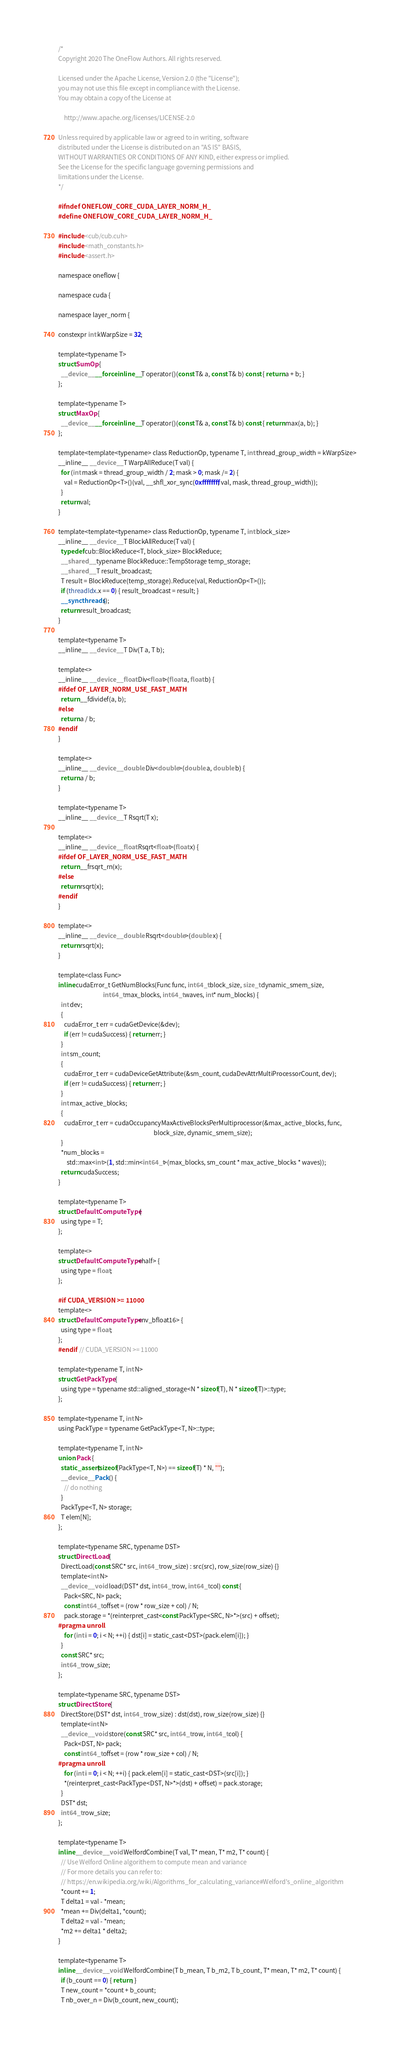Convert code to text. <code><loc_0><loc_0><loc_500><loc_500><_Cuda_>/*
Copyright 2020 The OneFlow Authors. All rights reserved.

Licensed under the Apache License, Version 2.0 (the "License");
you may not use this file except in compliance with the License.
You may obtain a copy of the License at

    http://www.apache.org/licenses/LICENSE-2.0

Unless required by applicable law or agreed to in writing, software
distributed under the License is distributed on an "AS IS" BASIS,
WITHOUT WARRANTIES OR CONDITIONS OF ANY KIND, either express or implied.
See the License for the specific language governing permissions and
limitations under the License.
*/

#ifndef ONEFLOW_CORE_CUDA_LAYER_NORM_H_
#define ONEFLOW_CORE_CUDA_LAYER_NORM_H_

#include <cub/cub.cuh>
#include <math_constants.h>
#include <assert.h>

namespace oneflow {

namespace cuda {

namespace layer_norm {

constexpr int kWarpSize = 32;

template<typename T>
struct SumOp {
  __device__ __forceinline__ T operator()(const T& a, const T& b) const { return a + b; }
};

template<typename T>
struct MaxOp {
  __device__ __forceinline__ T operator()(const T& a, const T& b) const { return max(a, b); }
};

template<template<typename> class ReductionOp, typename T, int thread_group_width = kWarpSize>
__inline__ __device__ T WarpAllReduce(T val) {
  for (int mask = thread_group_width / 2; mask > 0; mask /= 2) {
    val = ReductionOp<T>()(val, __shfl_xor_sync(0xffffffff, val, mask, thread_group_width));
  }
  return val;
}

template<template<typename> class ReductionOp, typename T, int block_size>
__inline__ __device__ T BlockAllReduce(T val) {
  typedef cub::BlockReduce<T, block_size> BlockReduce;
  __shared__ typename BlockReduce::TempStorage temp_storage;
  __shared__ T result_broadcast;
  T result = BlockReduce(temp_storage).Reduce(val, ReductionOp<T>());
  if (threadIdx.x == 0) { result_broadcast = result; }
  __syncthreads();
  return result_broadcast;
}

template<typename T>
__inline__ __device__ T Div(T a, T b);

template<>
__inline__ __device__ float Div<float>(float a, float b) {
#ifdef OF_LAYER_NORM_USE_FAST_MATH
  return __fdividef(a, b);
#else
  return a / b;
#endif
}

template<>
__inline__ __device__ double Div<double>(double a, double b) {
  return a / b;
}

template<typename T>
__inline__ __device__ T Rsqrt(T x);

template<>
__inline__ __device__ float Rsqrt<float>(float x) {
#ifdef OF_LAYER_NORM_USE_FAST_MATH
  return __frsqrt_rn(x);
#else
  return rsqrt(x);
#endif
}

template<>
__inline__ __device__ double Rsqrt<double>(double x) {
  return rsqrt(x);
}

template<class Func>
inline cudaError_t GetNumBlocks(Func func, int64_t block_size, size_t dynamic_smem_size,
                                int64_t max_blocks, int64_t waves, int* num_blocks) {
  int dev;
  {
    cudaError_t err = cudaGetDevice(&dev);
    if (err != cudaSuccess) { return err; }
  }
  int sm_count;
  {
    cudaError_t err = cudaDeviceGetAttribute(&sm_count, cudaDevAttrMultiProcessorCount, dev);
    if (err != cudaSuccess) { return err; }
  }
  int max_active_blocks;
  {
    cudaError_t err = cudaOccupancyMaxActiveBlocksPerMultiprocessor(&max_active_blocks, func,
                                                                    block_size, dynamic_smem_size);
  }
  *num_blocks =
      std::max<int>(1, std::min<int64_t>(max_blocks, sm_count * max_active_blocks * waves));
  return cudaSuccess;
}

template<typename T>
struct DefaultComputeType {
  using type = T;
};

template<>
struct DefaultComputeType<half> {
  using type = float;
};

#if CUDA_VERSION >= 11000
template<>
struct DefaultComputeType<nv_bfloat16> {
  using type = float;
};
#endif  // CUDA_VERSION >= 11000

template<typename T, int N>
struct GetPackType {
  using type = typename std::aligned_storage<N * sizeof(T), N * sizeof(T)>::type;
};

template<typename T, int N>
using PackType = typename GetPackType<T, N>::type;

template<typename T, int N>
union Pack {
  static_assert(sizeof(PackType<T, N>) == sizeof(T) * N, "");
  __device__ Pack() {
    // do nothing
  }
  PackType<T, N> storage;
  T elem[N];
};

template<typename SRC, typename DST>
struct DirectLoad {
  DirectLoad(const SRC* src, int64_t row_size) : src(src), row_size(row_size) {}
  template<int N>
  __device__ void load(DST* dst, int64_t row, int64_t col) const {
    Pack<SRC, N> pack;
    const int64_t offset = (row * row_size + col) / N;
    pack.storage = *(reinterpret_cast<const PackType<SRC, N>*>(src) + offset);
#pragma unroll
    for (int i = 0; i < N; ++i) { dst[i] = static_cast<DST>(pack.elem[i]); }
  }
  const SRC* src;
  int64_t row_size;
};

template<typename SRC, typename DST>
struct DirectStore {
  DirectStore(DST* dst, int64_t row_size) : dst(dst), row_size(row_size) {}
  template<int N>
  __device__ void store(const SRC* src, int64_t row, int64_t col) {
    Pack<DST, N> pack;
    const int64_t offset = (row * row_size + col) / N;
#pragma unroll
    for (int i = 0; i < N; ++i) { pack.elem[i] = static_cast<DST>(src[i]); }
    *(reinterpret_cast<PackType<DST, N>*>(dst) + offset) = pack.storage;
  }
  DST* dst;
  int64_t row_size;
};

template<typename T>
inline __device__ void WelfordCombine(T val, T* mean, T* m2, T* count) {
  // Use Welford Online algorithem to compute mean and variance
  // For more details you can refer to:
  // https://en.wikipedia.org/wiki/Algorithms_for_calculating_variance#Welford's_online_algorithm
  *count += 1;
  T delta1 = val - *mean;
  *mean += Div(delta1, *count);
  T delta2 = val - *mean;
  *m2 += delta1 * delta2;
}

template<typename T>
inline __device__ void WelfordCombine(T b_mean, T b_m2, T b_count, T* mean, T* m2, T* count) {
  if (b_count == 0) { return; }
  T new_count = *count + b_count;
  T nb_over_n = Div(b_count, new_count);</code> 